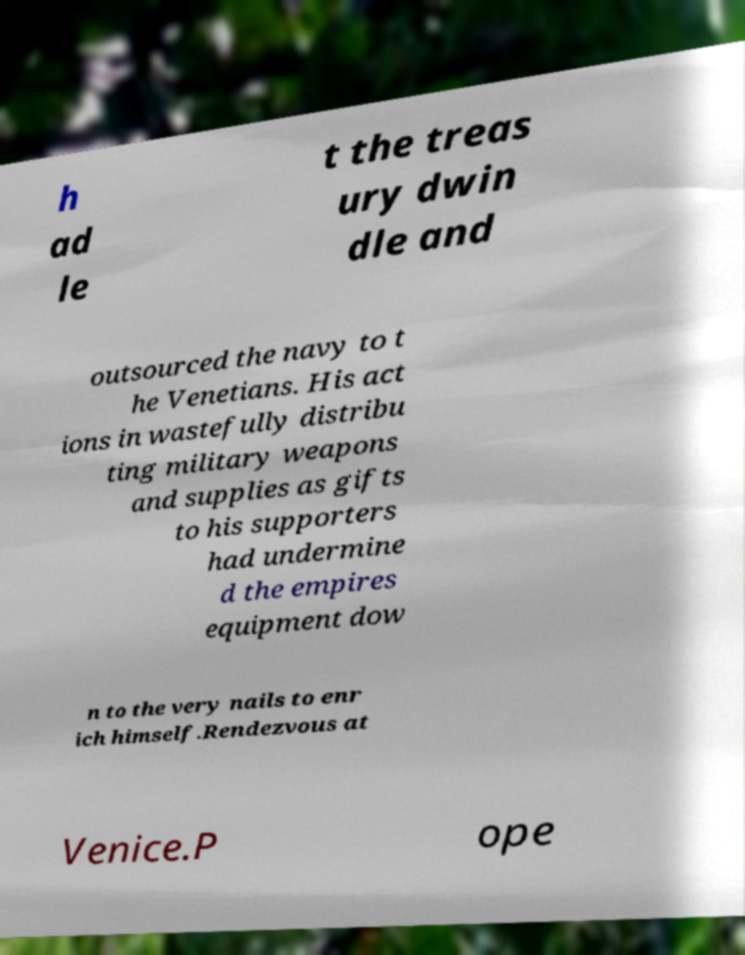Can you accurately transcribe the text from the provided image for me? h ad le t the treas ury dwin dle and outsourced the navy to t he Venetians. His act ions in wastefully distribu ting military weapons and supplies as gifts to his supporters had undermine d the empires equipment dow n to the very nails to enr ich himself.Rendezvous at Venice.P ope 